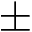<formula> <loc_0><loc_0><loc_500><loc_500>\pm</formula> 